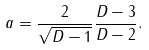Convert formula to latex. <formula><loc_0><loc_0><loc_500><loc_500>a = { \frac { 2 } { \sqrt { D - 1 } } } { \frac { D - 3 } { D - 2 } } .</formula> 